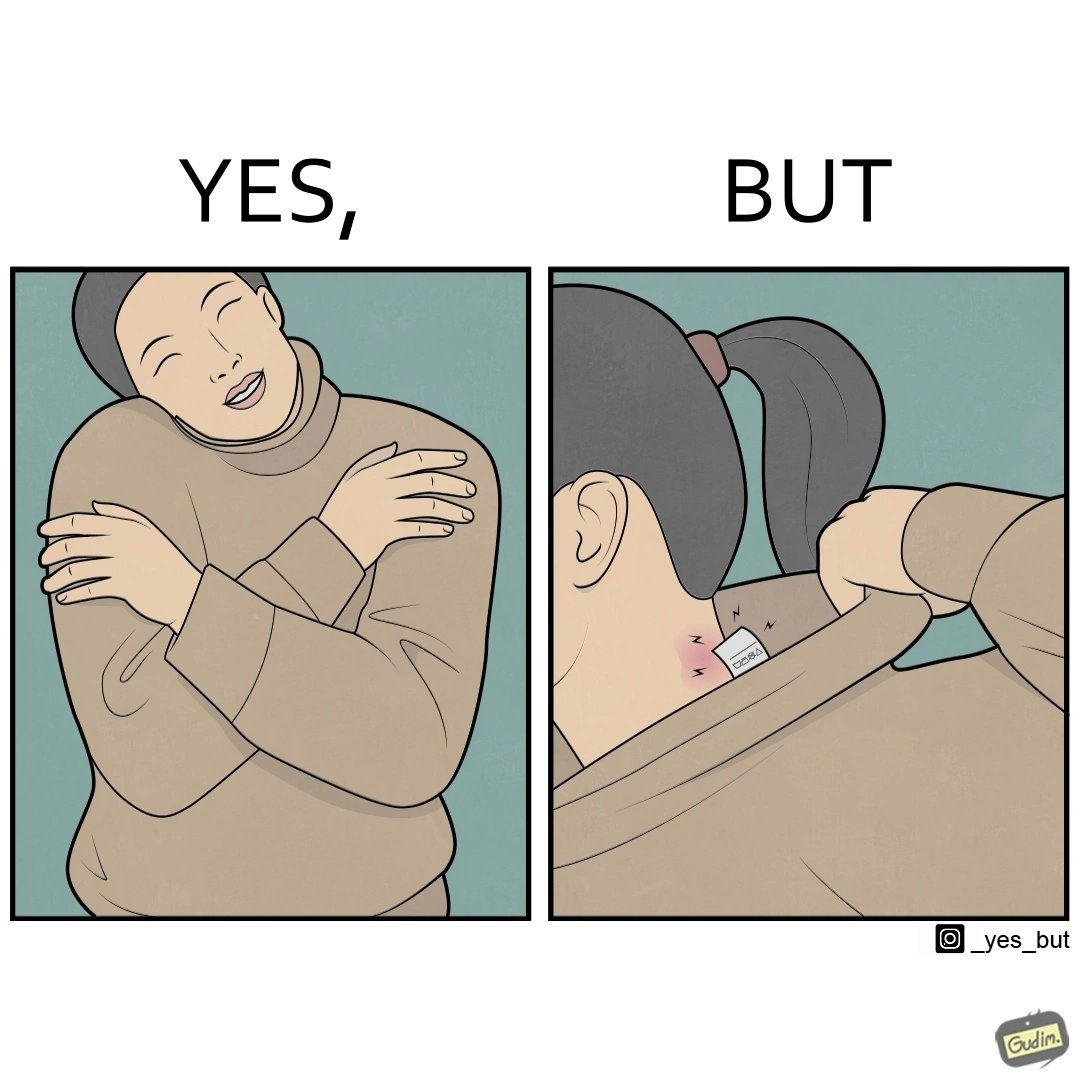What makes this image funny or satirical? The images are funny since it shows how even though sweaters and other clothings provide much comfort, a tiny manufacturers tag ends up causing the user a lot of discomfort due to constant scratching 